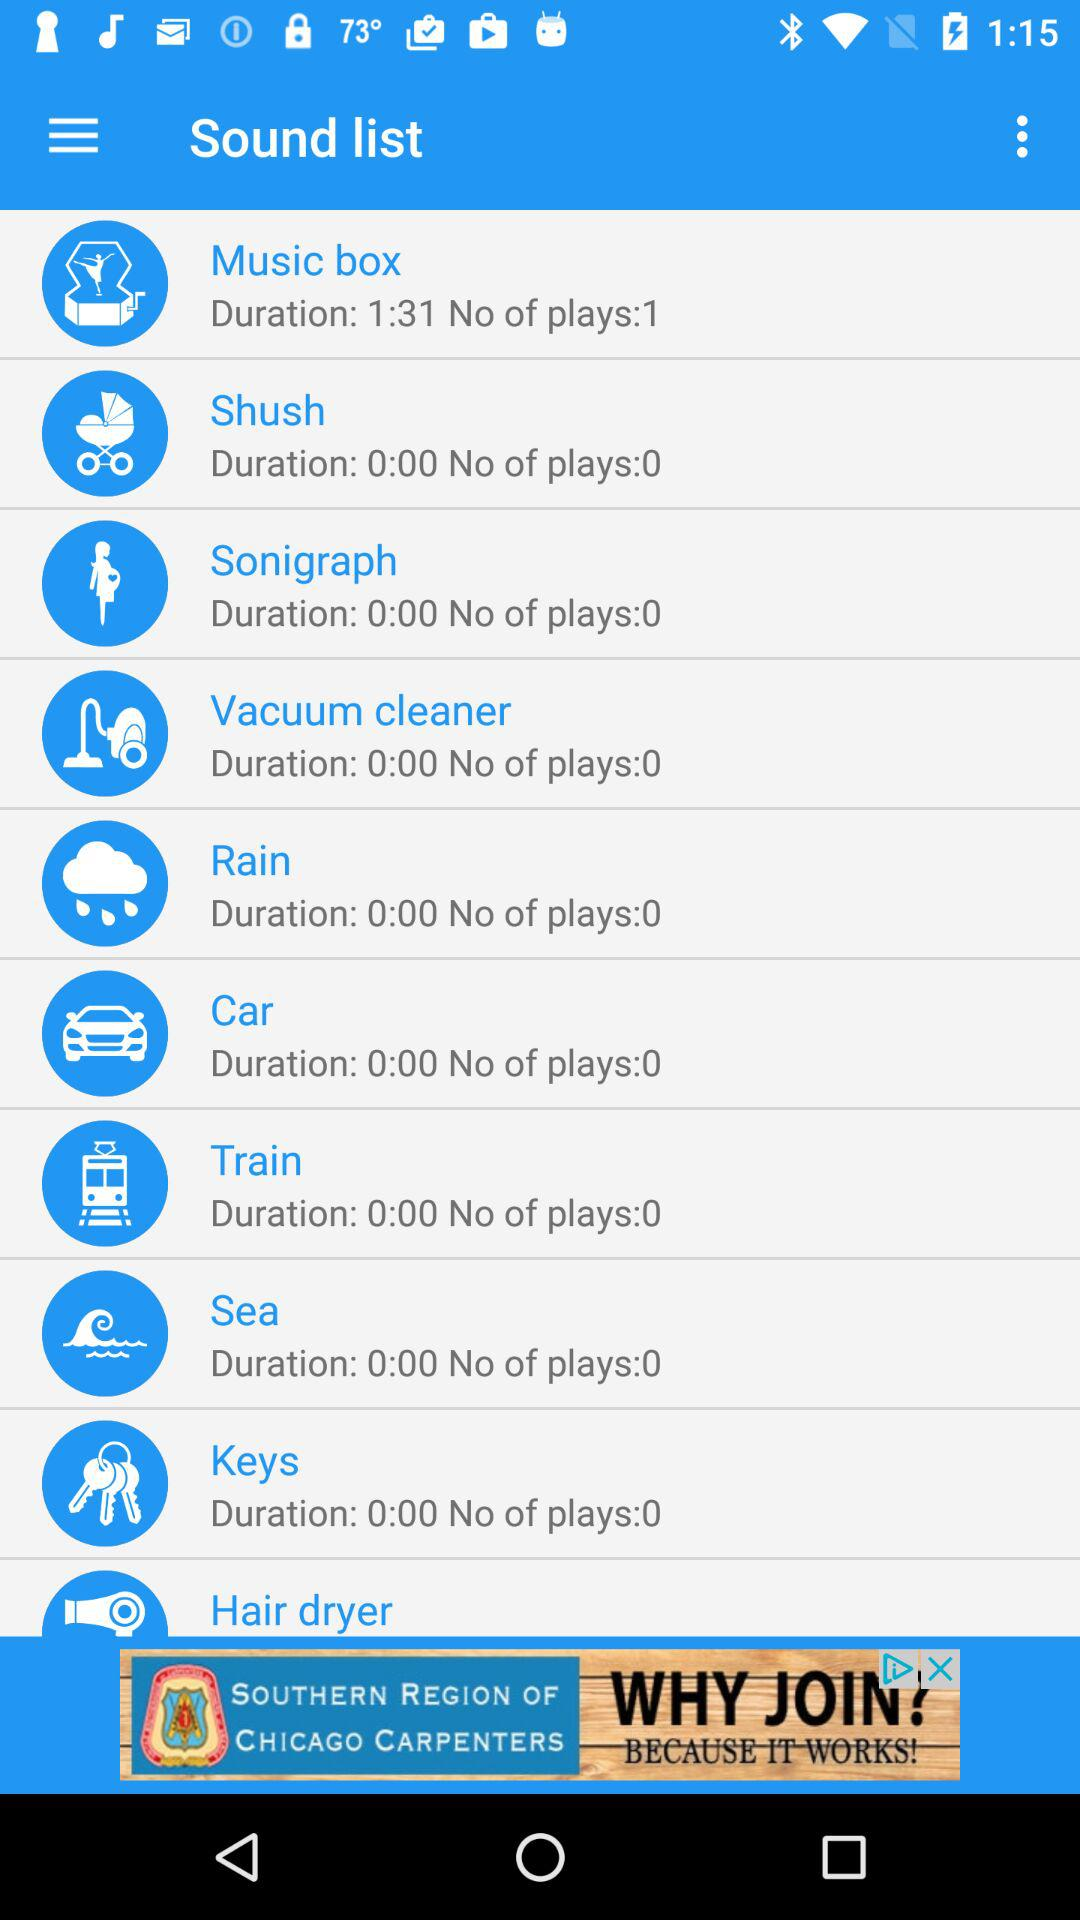What is the no. of plays of "Music box"? The no. of plays of "Music box" is 1. 